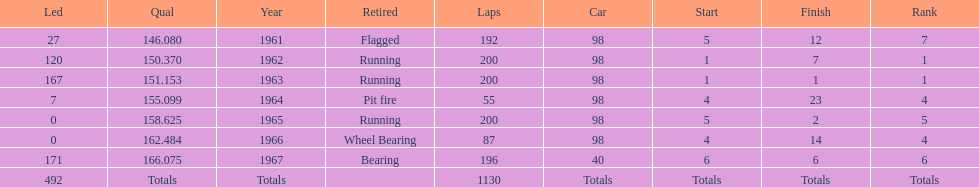What year(s) did parnelli finish at least 4th or better? 1963, 1965. 